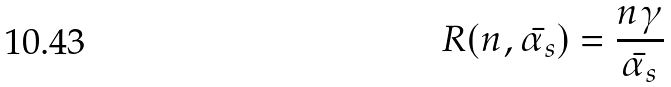<formula> <loc_0><loc_0><loc_500><loc_500>R ( n , \bar { \alpha _ { s } } ) = \frac { n \gamma } { \bar { \alpha _ { s } } }</formula> 